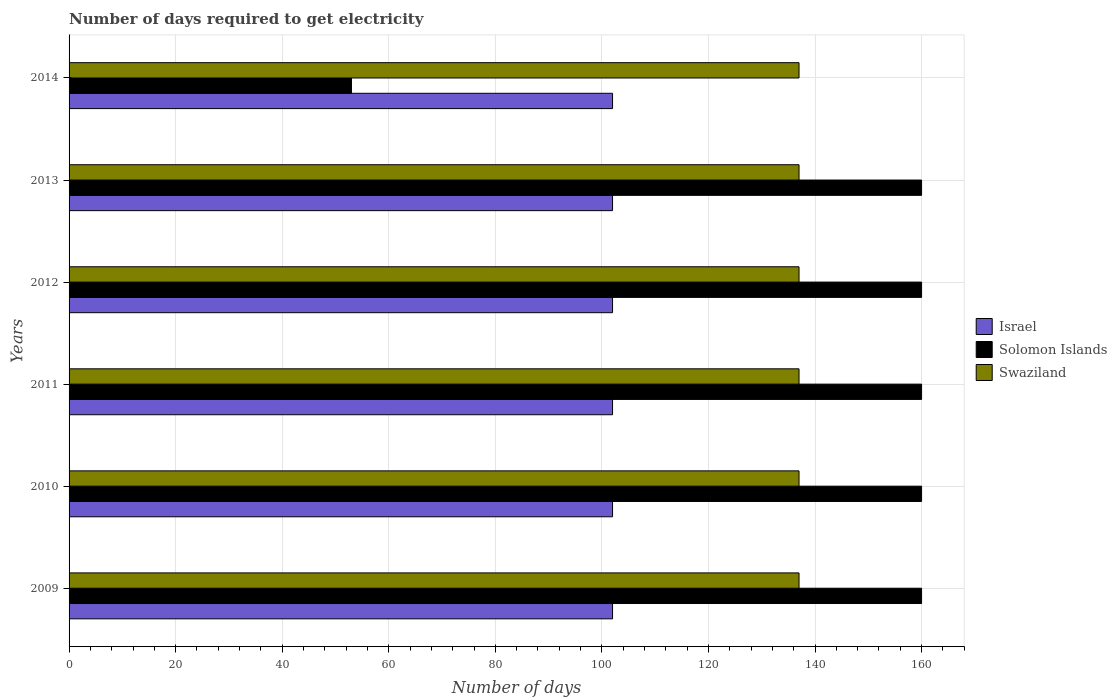Are the number of bars on each tick of the Y-axis equal?
Offer a very short reply. Yes. How many bars are there on the 5th tick from the top?
Make the answer very short. 3. How many bars are there on the 3rd tick from the bottom?
Your response must be concise. 3. What is the label of the 3rd group of bars from the top?
Provide a short and direct response. 2012. In how many cases, is the number of bars for a given year not equal to the number of legend labels?
Your answer should be very brief. 0. What is the number of days required to get electricity in in Swaziland in 2009?
Your answer should be very brief. 137. Across all years, what is the maximum number of days required to get electricity in in Swaziland?
Ensure brevity in your answer.  137. Across all years, what is the minimum number of days required to get electricity in in Swaziland?
Provide a succinct answer. 137. In which year was the number of days required to get electricity in in Swaziland minimum?
Your answer should be compact. 2009. What is the total number of days required to get electricity in in Israel in the graph?
Ensure brevity in your answer.  612. What is the difference between the number of days required to get electricity in in Solomon Islands in 2010 and that in 2014?
Your response must be concise. 107. What is the difference between the number of days required to get electricity in in Israel in 2011 and the number of days required to get electricity in in Solomon Islands in 2014?
Your answer should be compact. 49. What is the average number of days required to get electricity in in Swaziland per year?
Make the answer very short. 137. In the year 2011, what is the difference between the number of days required to get electricity in in Solomon Islands and number of days required to get electricity in in Swaziland?
Make the answer very short. 23. In how many years, is the number of days required to get electricity in in Swaziland greater than 148 days?
Keep it short and to the point. 0. What is the ratio of the number of days required to get electricity in in Israel in 2013 to that in 2014?
Offer a very short reply. 1. Is the number of days required to get electricity in in Israel in 2013 less than that in 2014?
Offer a very short reply. No. What is the difference between the highest and the second highest number of days required to get electricity in in Israel?
Offer a terse response. 0. What is the difference between the highest and the lowest number of days required to get electricity in in Solomon Islands?
Provide a short and direct response. 107. In how many years, is the number of days required to get electricity in in Solomon Islands greater than the average number of days required to get electricity in in Solomon Islands taken over all years?
Keep it short and to the point. 5. What does the 3rd bar from the bottom in 2012 represents?
Offer a terse response. Swaziland. Is it the case that in every year, the sum of the number of days required to get electricity in in Solomon Islands and number of days required to get electricity in in Israel is greater than the number of days required to get electricity in in Swaziland?
Make the answer very short. Yes. Are all the bars in the graph horizontal?
Give a very brief answer. Yes. What is the difference between two consecutive major ticks on the X-axis?
Your response must be concise. 20. Does the graph contain any zero values?
Keep it short and to the point. No. Does the graph contain grids?
Provide a short and direct response. Yes. What is the title of the graph?
Your response must be concise. Number of days required to get electricity. Does "Niger" appear as one of the legend labels in the graph?
Offer a terse response. No. What is the label or title of the X-axis?
Your answer should be compact. Number of days. What is the label or title of the Y-axis?
Keep it short and to the point. Years. What is the Number of days in Israel in 2009?
Your answer should be compact. 102. What is the Number of days of Solomon Islands in 2009?
Your answer should be very brief. 160. What is the Number of days of Swaziland in 2009?
Provide a succinct answer. 137. What is the Number of days in Israel in 2010?
Give a very brief answer. 102. What is the Number of days of Solomon Islands in 2010?
Give a very brief answer. 160. What is the Number of days in Swaziland in 2010?
Your answer should be compact. 137. What is the Number of days in Israel in 2011?
Offer a very short reply. 102. What is the Number of days in Solomon Islands in 2011?
Give a very brief answer. 160. What is the Number of days of Swaziland in 2011?
Provide a short and direct response. 137. What is the Number of days of Israel in 2012?
Provide a short and direct response. 102. What is the Number of days in Solomon Islands in 2012?
Give a very brief answer. 160. What is the Number of days in Swaziland in 2012?
Make the answer very short. 137. What is the Number of days of Israel in 2013?
Keep it short and to the point. 102. What is the Number of days in Solomon Islands in 2013?
Provide a short and direct response. 160. What is the Number of days in Swaziland in 2013?
Your response must be concise. 137. What is the Number of days of Israel in 2014?
Provide a short and direct response. 102. What is the Number of days of Swaziland in 2014?
Provide a succinct answer. 137. Across all years, what is the maximum Number of days of Israel?
Your answer should be compact. 102. Across all years, what is the maximum Number of days of Solomon Islands?
Provide a succinct answer. 160. Across all years, what is the maximum Number of days in Swaziland?
Ensure brevity in your answer.  137. Across all years, what is the minimum Number of days in Israel?
Provide a short and direct response. 102. Across all years, what is the minimum Number of days of Swaziland?
Offer a terse response. 137. What is the total Number of days in Israel in the graph?
Provide a short and direct response. 612. What is the total Number of days of Solomon Islands in the graph?
Provide a short and direct response. 853. What is the total Number of days of Swaziland in the graph?
Keep it short and to the point. 822. What is the difference between the Number of days in Swaziland in 2009 and that in 2010?
Keep it short and to the point. 0. What is the difference between the Number of days of Swaziland in 2009 and that in 2011?
Make the answer very short. 0. What is the difference between the Number of days in Swaziland in 2009 and that in 2012?
Provide a succinct answer. 0. What is the difference between the Number of days of Israel in 2009 and that in 2014?
Offer a terse response. 0. What is the difference between the Number of days of Solomon Islands in 2009 and that in 2014?
Give a very brief answer. 107. What is the difference between the Number of days of Solomon Islands in 2010 and that in 2011?
Offer a terse response. 0. What is the difference between the Number of days in Israel in 2010 and that in 2012?
Your response must be concise. 0. What is the difference between the Number of days of Israel in 2010 and that in 2013?
Your answer should be very brief. 0. What is the difference between the Number of days of Solomon Islands in 2010 and that in 2013?
Provide a succinct answer. 0. What is the difference between the Number of days of Israel in 2010 and that in 2014?
Your answer should be compact. 0. What is the difference between the Number of days of Solomon Islands in 2010 and that in 2014?
Ensure brevity in your answer.  107. What is the difference between the Number of days in Israel in 2011 and that in 2012?
Provide a succinct answer. 0. What is the difference between the Number of days of Solomon Islands in 2011 and that in 2012?
Provide a succinct answer. 0. What is the difference between the Number of days in Swaziland in 2011 and that in 2012?
Provide a short and direct response. 0. What is the difference between the Number of days of Israel in 2011 and that in 2013?
Your answer should be compact. 0. What is the difference between the Number of days in Solomon Islands in 2011 and that in 2013?
Your answer should be very brief. 0. What is the difference between the Number of days in Israel in 2011 and that in 2014?
Offer a terse response. 0. What is the difference between the Number of days in Solomon Islands in 2011 and that in 2014?
Your answer should be compact. 107. What is the difference between the Number of days in Swaziland in 2011 and that in 2014?
Your response must be concise. 0. What is the difference between the Number of days in Israel in 2012 and that in 2014?
Offer a terse response. 0. What is the difference between the Number of days in Solomon Islands in 2012 and that in 2014?
Offer a very short reply. 107. What is the difference between the Number of days in Israel in 2013 and that in 2014?
Give a very brief answer. 0. What is the difference between the Number of days of Solomon Islands in 2013 and that in 2014?
Keep it short and to the point. 107. What is the difference between the Number of days of Israel in 2009 and the Number of days of Solomon Islands in 2010?
Offer a terse response. -58. What is the difference between the Number of days of Israel in 2009 and the Number of days of Swaziland in 2010?
Your answer should be very brief. -35. What is the difference between the Number of days in Solomon Islands in 2009 and the Number of days in Swaziland in 2010?
Ensure brevity in your answer.  23. What is the difference between the Number of days of Israel in 2009 and the Number of days of Solomon Islands in 2011?
Provide a succinct answer. -58. What is the difference between the Number of days of Israel in 2009 and the Number of days of Swaziland in 2011?
Make the answer very short. -35. What is the difference between the Number of days of Israel in 2009 and the Number of days of Solomon Islands in 2012?
Give a very brief answer. -58. What is the difference between the Number of days of Israel in 2009 and the Number of days of Swaziland in 2012?
Keep it short and to the point. -35. What is the difference between the Number of days of Israel in 2009 and the Number of days of Solomon Islands in 2013?
Provide a succinct answer. -58. What is the difference between the Number of days of Israel in 2009 and the Number of days of Swaziland in 2013?
Your answer should be compact. -35. What is the difference between the Number of days of Solomon Islands in 2009 and the Number of days of Swaziland in 2013?
Your response must be concise. 23. What is the difference between the Number of days in Israel in 2009 and the Number of days in Swaziland in 2014?
Keep it short and to the point. -35. What is the difference between the Number of days of Israel in 2010 and the Number of days of Solomon Islands in 2011?
Offer a terse response. -58. What is the difference between the Number of days in Israel in 2010 and the Number of days in Swaziland in 2011?
Your answer should be compact. -35. What is the difference between the Number of days in Israel in 2010 and the Number of days in Solomon Islands in 2012?
Ensure brevity in your answer.  -58. What is the difference between the Number of days of Israel in 2010 and the Number of days of Swaziland in 2012?
Provide a succinct answer. -35. What is the difference between the Number of days in Solomon Islands in 2010 and the Number of days in Swaziland in 2012?
Provide a short and direct response. 23. What is the difference between the Number of days in Israel in 2010 and the Number of days in Solomon Islands in 2013?
Provide a short and direct response. -58. What is the difference between the Number of days in Israel in 2010 and the Number of days in Swaziland in 2013?
Your answer should be compact. -35. What is the difference between the Number of days of Solomon Islands in 2010 and the Number of days of Swaziland in 2013?
Keep it short and to the point. 23. What is the difference between the Number of days in Israel in 2010 and the Number of days in Solomon Islands in 2014?
Your response must be concise. 49. What is the difference between the Number of days of Israel in 2010 and the Number of days of Swaziland in 2014?
Keep it short and to the point. -35. What is the difference between the Number of days of Solomon Islands in 2010 and the Number of days of Swaziland in 2014?
Give a very brief answer. 23. What is the difference between the Number of days of Israel in 2011 and the Number of days of Solomon Islands in 2012?
Offer a terse response. -58. What is the difference between the Number of days of Israel in 2011 and the Number of days of Swaziland in 2012?
Offer a terse response. -35. What is the difference between the Number of days in Solomon Islands in 2011 and the Number of days in Swaziland in 2012?
Offer a terse response. 23. What is the difference between the Number of days in Israel in 2011 and the Number of days in Solomon Islands in 2013?
Offer a terse response. -58. What is the difference between the Number of days of Israel in 2011 and the Number of days of Swaziland in 2013?
Ensure brevity in your answer.  -35. What is the difference between the Number of days of Solomon Islands in 2011 and the Number of days of Swaziland in 2013?
Provide a short and direct response. 23. What is the difference between the Number of days of Israel in 2011 and the Number of days of Solomon Islands in 2014?
Ensure brevity in your answer.  49. What is the difference between the Number of days in Israel in 2011 and the Number of days in Swaziland in 2014?
Ensure brevity in your answer.  -35. What is the difference between the Number of days of Solomon Islands in 2011 and the Number of days of Swaziland in 2014?
Provide a short and direct response. 23. What is the difference between the Number of days in Israel in 2012 and the Number of days in Solomon Islands in 2013?
Provide a short and direct response. -58. What is the difference between the Number of days of Israel in 2012 and the Number of days of Swaziland in 2013?
Provide a succinct answer. -35. What is the difference between the Number of days in Israel in 2012 and the Number of days in Swaziland in 2014?
Your answer should be very brief. -35. What is the difference between the Number of days in Solomon Islands in 2012 and the Number of days in Swaziland in 2014?
Ensure brevity in your answer.  23. What is the difference between the Number of days in Israel in 2013 and the Number of days in Swaziland in 2014?
Give a very brief answer. -35. What is the difference between the Number of days of Solomon Islands in 2013 and the Number of days of Swaziland in 2014?
Your answer should be very brief. 23. What is the average Number of days in Israel per year?
Give a very brief answer. 102. What is the average Number of days in Solomon Islands per year?
Make the answer very short. 142.17. What is the average Number of days of Swaziland per year?
Keep it short and to the point. 137. In the year 2009, what is the difference between the Number of days in Israel and Number of days in Solomon Islands?
Offer a very short reply. -58. In the year 2009, what is the difference between the Number of days in Israel and Number of days in Swaziland?
Offer a terse response. -35. In the year 2010, what is the difference between the Number of days of Israel and Number of days of Solomon Islands?
Your answer should be compact. -58. In the year 2010, what is the difference between the Number of days of Israel and Number of days of Swaziland?
Give a very brief answer. -35. In the year 2011, what is the difference between the Number of days of Israel and Number of days of Solomon Islands?
Ensure brevity in your answer.  -58. In the year 2011, what is the difference between the Number of days of Israel and Number of days of Swaziland?
Provide a short and direct response. -35. In the year 2012, what is the difference between the Number of days of Israel and Number of days of Solomon Islands?
Offer a terse response. -58. In the year 2012, what is the difference between the Number of days in Israel and Number of days in Swaziland?
Offer a very short reply. -35. In the year 2012, what is the difference between the Number of days of Solomon Islands and Number of days of Swaziland?
Ensure brevity in your answer.  23. In the year 2013, what is the difference between the Number of days of Israel and Number of days of Solomon Islands?
Give a very brief answer. -58. In the year 2013, what is the difference between the Number of days of Israel and Number of days of Swaziland?
Ensure brevity in your answer.  -35. In the year 2013, what is the difference between the Number of days in Solomon Islands and Number of days in Swaziland?
Your answer should be compact. 23. In the year 2014, what is the difference between the Number of days of Israel and Number of days of Swaziland?
Keep it short and to the point. -35. In the year 2014, what is the difference between the Number of days of Solomon Islands and Number of days of Swaziland?
Your answer should be very brief. -84. What is the ratio of the Number of days in Solomon Islands in 2009 to that in 2010?
Provide a succinct answer. 1. What is the ratio of the Number of days in Swaziland in 2009 to that in 2010?
Give a very brief answer. 1. What is the ratio of the Number of days of Solomon Islands in 2009 to that in 2011?
Offer a terse response. 1. What is the ratio of the Number of days of Israel in 2009 to that in 2012?
Make the answer very short. 1. What is the ratio of the Number of days of Solomon Islands in 2009 to that in 2012?
Your answer should be very brief. 1. What is the ratio of the Number of days in Israel in 2009 to that in 2013?
Your answer should be very brief. 1. What is the ratio of the Number of days of Solomon Islands in 2009 to that in 2014?
Your answer should be very brief. 3.02. What is the ratio of the Number of days of Solomon Islands in 2010 to that in 2011?
Give a very brief answer. 1. What is the ratio of the Number of days in Swaziland in 2010 to that in 2011?
Provide a succinct answer. 1. What is the ratio of the Number of days of Swaziland in 2010 to that in 2013?
Make the answer very short. 1. What is the ratio of the Number of days in Israel in 2010 to that in 2014?
Offer a terse response. 1. What is the ratio of the Number of days of Solomon Islands in 2010 to that in 2014?
Your answer should be compact. 3.02. What is the ratio of the Number of days of Swaziland in 2010 to that in 2014?
Your response must be concise. 1. What is the ratio of the Number of days in Solomon Islands in 2011 to that in 2012?
Provide a short and direct response. 1. What is the ratio of the Number of days of Swaziland in 2011 to that in 2012?
Ensure brevity in your answer.  1. What is the ratio of the Number of days of Israel in 2011 to that in 2013?
Ensure brevity in your answer.  1. What is the ratio of the Number of days of Swaziland in 2011 to that in 2013?
Offer a terse response. 1. What is the ratio of the Number of days in Israel in 2011 to that in 2014?
Provide a short and direct response. 1. What is the ratio of the Number of days of Solomon Islands in 2011 to that in 2014?
Provide a succinct answer. 3.02. What is the ratio of the Number of days of Israel in 2012 to that in 2013?
Your response must be concise. 1. What is the ratio of the Number of days of Solomon Islands in 2012 to that in 2014?
Provide a short and direct response. 3.02. What is the ratio of the Number of days of Swaziland in 2012 to that in 2014?
Provide a short and direct response. 1. What is the ratio of the Number of days of Solomon Islands in 2013 to that in 2014?
Give a very brief answer. 3.02. What is the ratio of the Number of days of Swaziland in 2013 to that in 2014?
Ensure brevity in your answer.  1. What is the difference between the highest and the second highest Number of days in Israel?
Offer a terse response. 0. What is the difference between the highest and the second highest Number of days of Solomon Islands?
Give a very brief answer. 0. What is the difference between the highest and the lowest Number of days of Solomon Islands?
Make the answer very short. 107. 